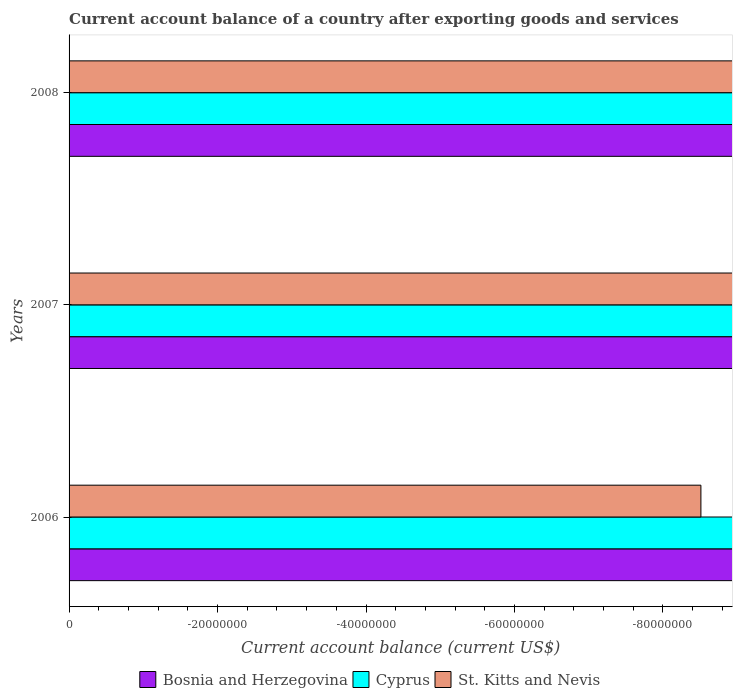Are the number of bars per tick equal to the number of legend labels?
Your answer should be compact. No. How many bars are there on the 3rd tick from the top?
Ensure brevity in your answer.  0. How many bars are there on the 2nd tick from the bottom?
Give a very brief answer. 0. In how many cases, is the number of bars for a given year not equal to the number of legend labels?
Provide a short and direct response. 3. What is the average account balance in Cyprus per year?
Offer a very short reply. 0. In how many years, is the account balance in Cyprus greater than -68000000 US$?
Ensure brevity in your answer.  0. Are all the bars in the graph horizontal?
Make the answer very short. Yes. Are the values on the major ticks of X-axis written in scientific E-notation?
Offer a terse response. No. Does the graph contain grids?
Offer a very short reply. No. Where does the legend appear in the graph?
Your response must be concise. Bottom center. What is the title of the graph?
Your answer should be very brief. Current account balance of a country after exporting goods and services. What is the label or title of the X-axis?
Provide a succinct answer. Current account balance (current US$). What is the label or title of the Y-axis?
Ensure brevity in your answer.  Years. What is the Current account balance (current US$) of St. Kitts and Nevis in 2006?
Provide a succinct answer. 0. What is the Current account balance (current US$) of Bosnia and Herzegovina in 2007?
Give a very brief answer. 0. What is the Current account balance (current US$) in St. Kitts and Nevis in 2007?
Offer a very short reply. 0. What is the Current account balance (current US$) of Cyprus in 2008?
Offer a terse response. 0. What is the total Current account balance (current US$) of Bosnia and Herzegovina in the graph?
Your response must be concise. 0. What is the total Current account balance (current US$) in Cyprus in the graph?
Keep it short and to the point. 0. 